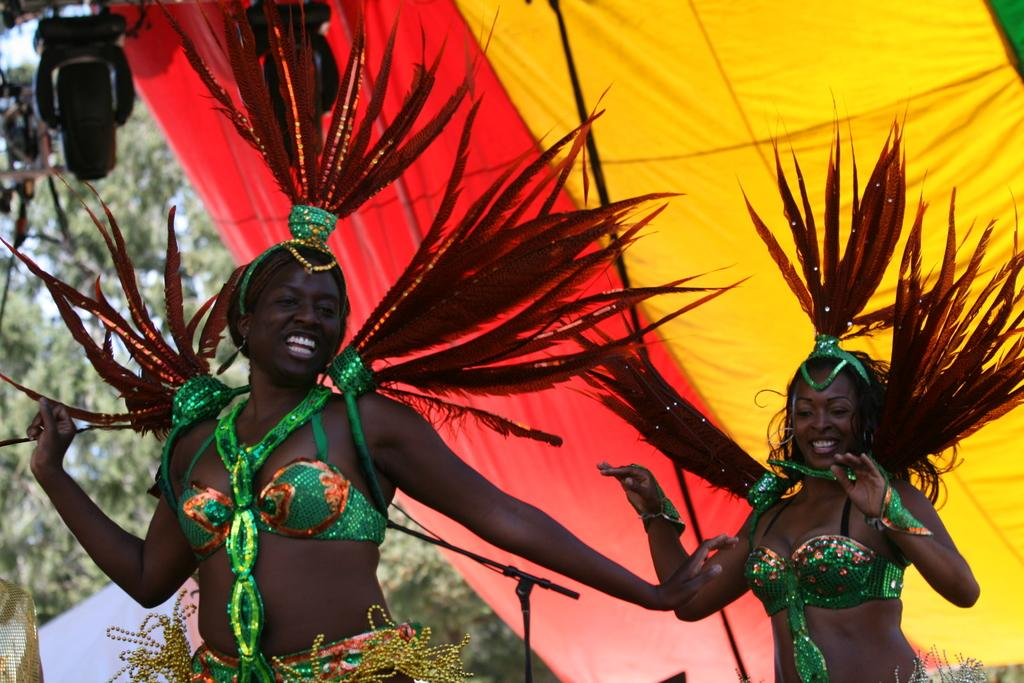How many women are in the foreground of the image? There are two women in the foreground of the image. What are the women wearing in the image? The women are wearing carnival costumes in the image. What can be seen in the background of the image? There is a tent, a light, trees, and the sky visible in the background of the image. What type of honey is being used to decorate the women's costumes in the image? There is no honey present in the image, and the women's costumes do not appear to be decorated with any honey. 